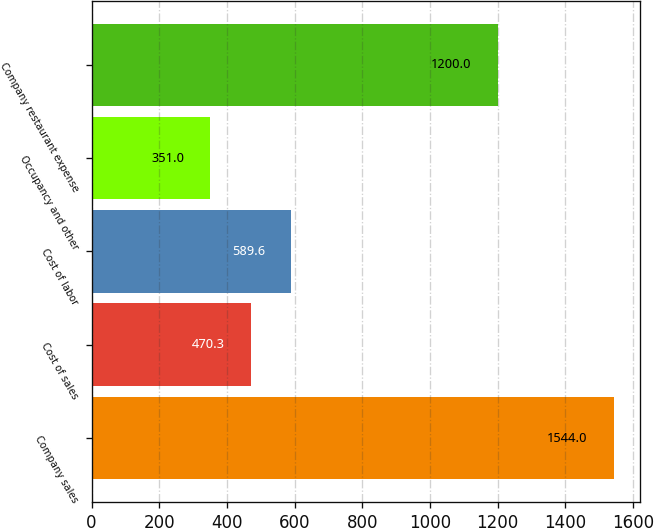Convert chart to OTSL. <chart><loc_0><loc_0><loc_500><loc_500><bar_chart><fcel>Company sales<fcel>Cost of sales<fcel>Cost of labor<fcel>Occupancy and other<fcel>Company restaurant expense<nl><fcel>1544<fcel>470.3<fcel>589.6<fcel>351<fcel>1200<nl></chart> 